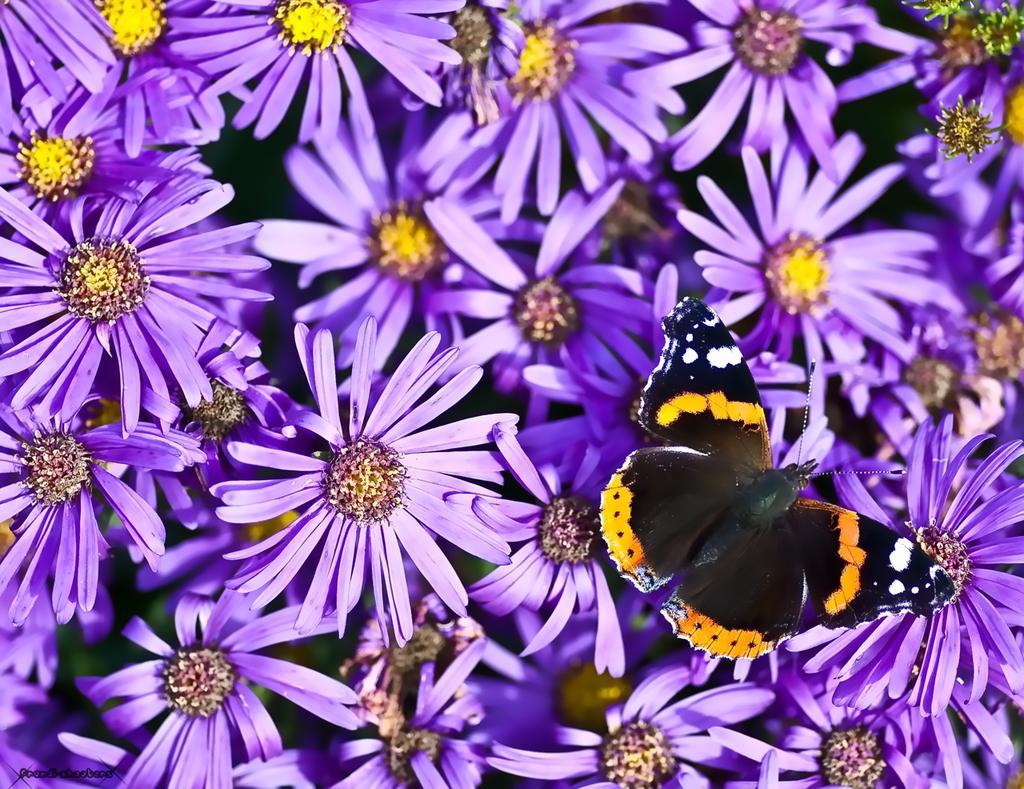How would you summarize this image in a sentence or two? In this image we can see some flowers and a butterfly. 